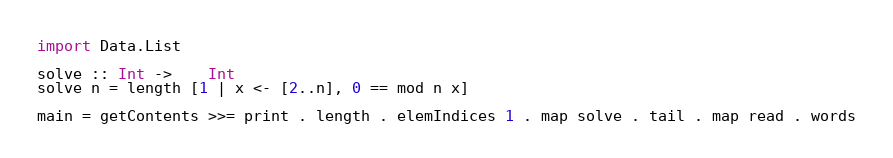Convert code to text. <code><loc_0><loc_0><loc_500><loc_500><_Haskell_>import Data.List

solve :: Int ->	Int
solve n = length [1 | x <- [2..n], 0 == mod n x]

main = getContents >>= print . length . elemIndices 1 . map solve . tail . map read . words</code> 